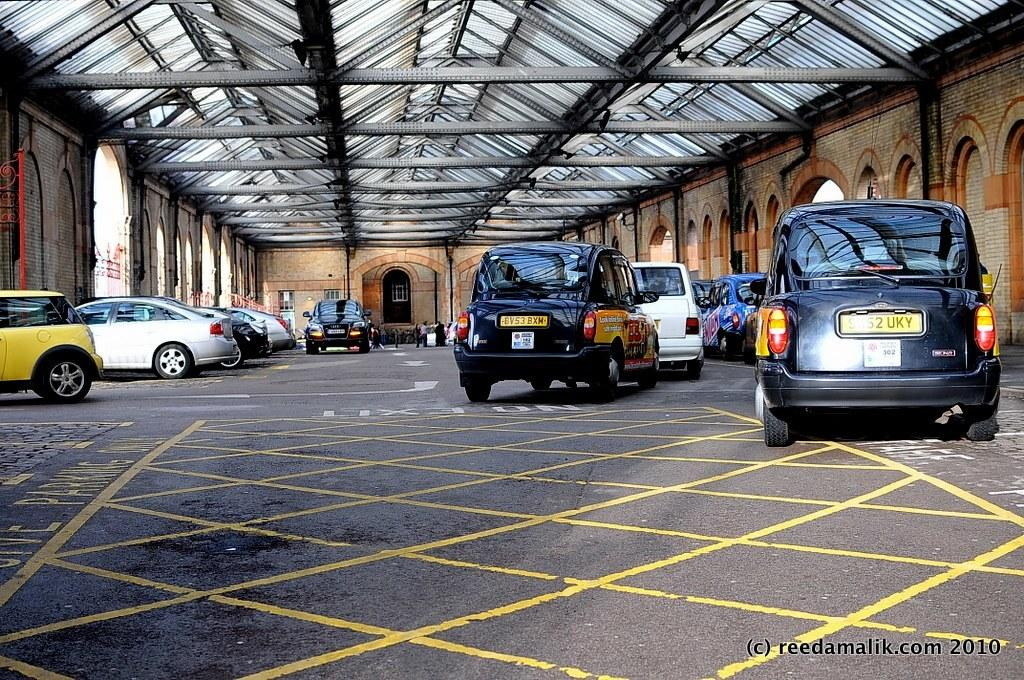Provide a one-sentence caption for the provided image. Vehicles parked outside a building with a license plate on the rear BV53BXH. 